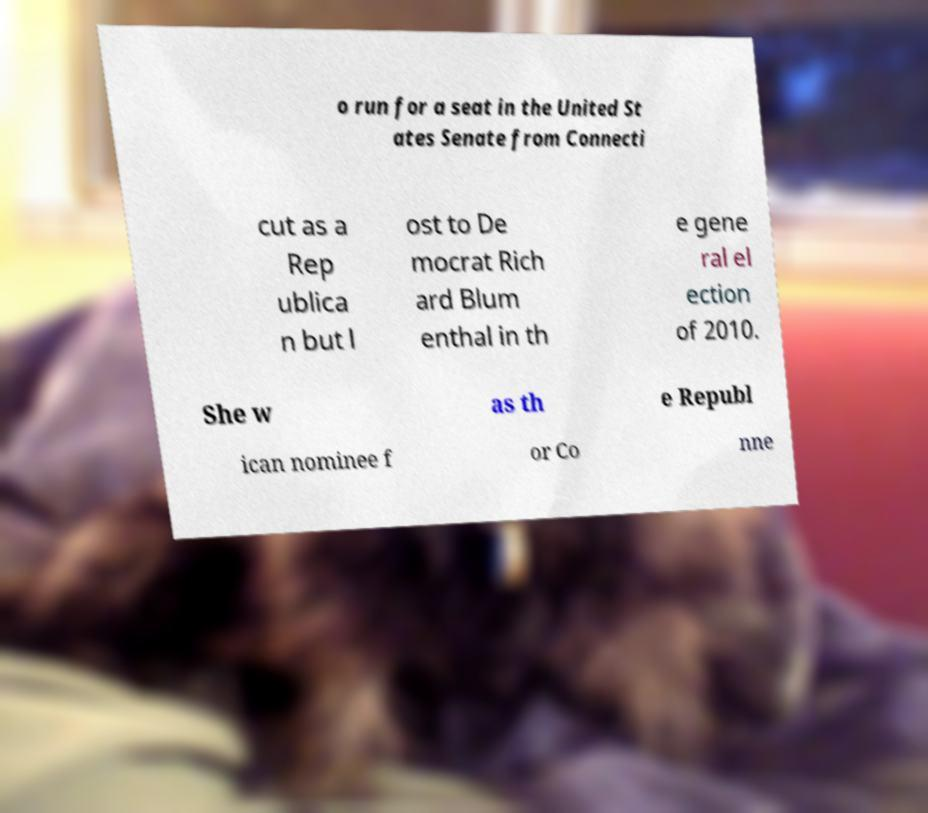Please read and relay the text visible in this image. What does it say? o run for a seat in the United St ates Senate from Connecti cut as a Rep ublica n but l ost to De mocrat Rich ard Blum enthal in th e gene ral el ection of 2010. She w as th e Republ ican nominee f or Co nne 